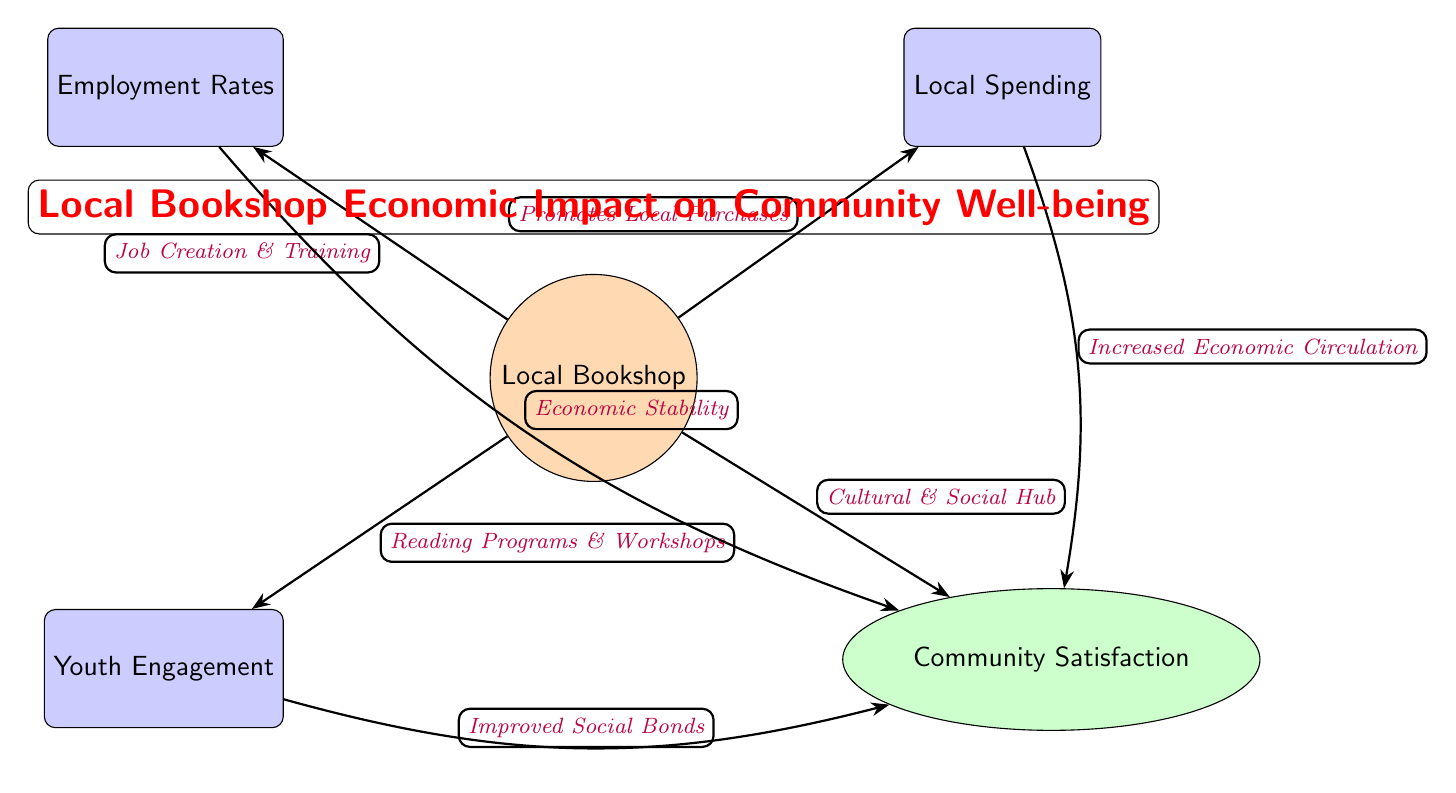What is the central node in the diagram? The central node in the diagram is the "Local Bookshop," which connects to various impacts on the community by illustrating its role and initiatives.
Answer: Local Bookshop How many impact metrics are shown in the diagram? The diagram features four impact metrics: Employment Rates, Local Spending, Youth Engagement, and Community Satisfaction. Therefore, the total count is derived directly from the nodes indicated in the diagram.
Answer: 4 What initiative connects the Local Bookshop to Employment Rates? The initiative connecting the Local Bookshop to Employment Rates is "Job Creation & Training," as shown in the directed edge linking these two nodes.
Answer: Job Creation & Training Which impact metric is linked to Cultural & Social Hub? The impact metric linked to the Cultural & Social Hub is "Community Satisfaction," as indicated by the arrow connecting the Local Bookshop to Community Satisfaction.
Answer: Community Satisfaction What two pathways lead to Community Satisfaction from the impact metrics? The two pathways leading to Community Satisfaction are from "Economic Stability" linked via Employment Rates and "Increased Economic Circulation" linked via Local Spending. This reflects two different impacts reinforcing community satisfaction.
Answer: Economic Stability and Increased Economic Circulation How does Youth Engagement influence Community Satisfaction? Youth Engagement influences Community Satisfaction through the relationship indicated by the arrow labeled "Improved Social Bonds," demonstrating how engagement fosters community ties, leading to greater satisfaction.
Answer: Improved Social Bonds What color represents the impact metrics in the diagram? The impact metrics are represented in blue, as indicated by the rectangle style shown in the diagram for these nodes.
Answer: Blue What is the overall theme represented in the diagram? The overall theme of the diagram emphasizes the economic impact of the Local Bookshop on the community's well-being through various initiatives and metrics linking back to community benefits.
Answer: Economic impact on community well-being How many direct connections does the Local Bookshop have? The Local Bookshop has four direct connections, shown as edges leading to four different impact nodes, reflecting its multifaceted contribution to the community.
Answer: 4 